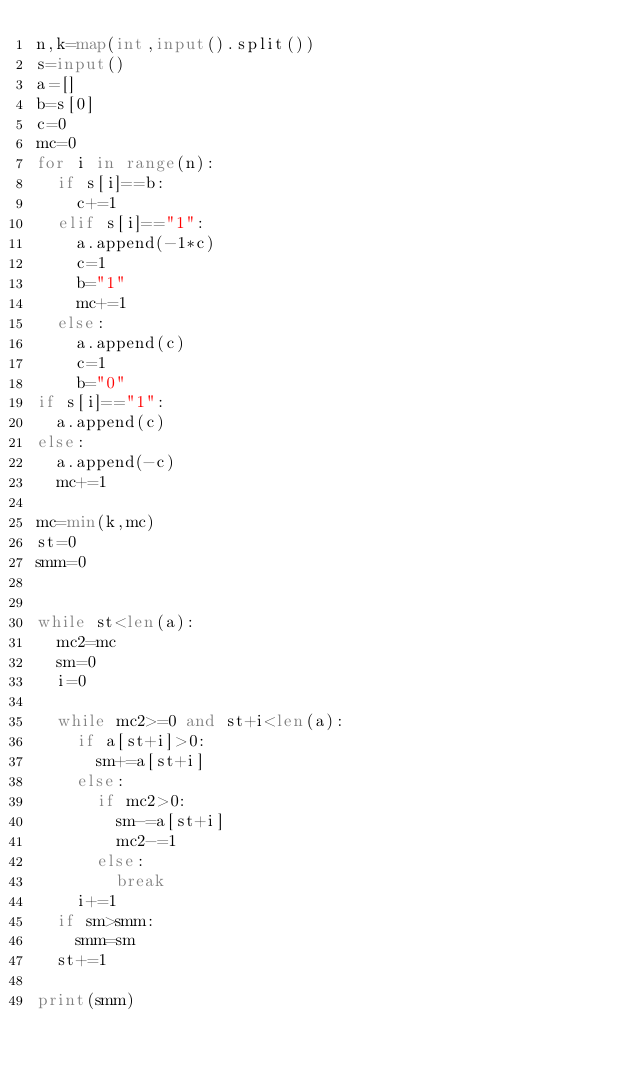Convert code to text. <code><loc_0><loc_0><loc_500><loc_500><_Python_>n,k=map(int,input().split())
s=input()
a=[]
b=s[0]
c=0
mc=0
for i in range(n):
  if s[i]==b:
    c+=1
  elif s[i]=="1":
    a.append(-1*c)
    c=1
    b="1"
    mc+=1
  else:
    a.append(c)
    c=1
    b="0"
if s[i]=="1":
  a.append(c)
else:
  a.append(-c)
  mc+=1

mc=min(k,mc)
st=0
smm=0


while st<len(a):
  mc2=mc
  sm=0
  i=0

  while mc2>=0 and st+i<len(a):
    if a[st+i]>0:
      sm+=a[st+i]
    else:
      if mc2>0:
        sm-=a[st+i]
        mc2-=1
      else:
        break
    i+=1
  if sm>smm:
    smm=sm
  st+=1

print(smm)</code> 